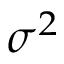<formula> <loc_0><loc_0><loc_500><loc_500>\sigma ^ { 2 }</formula> 